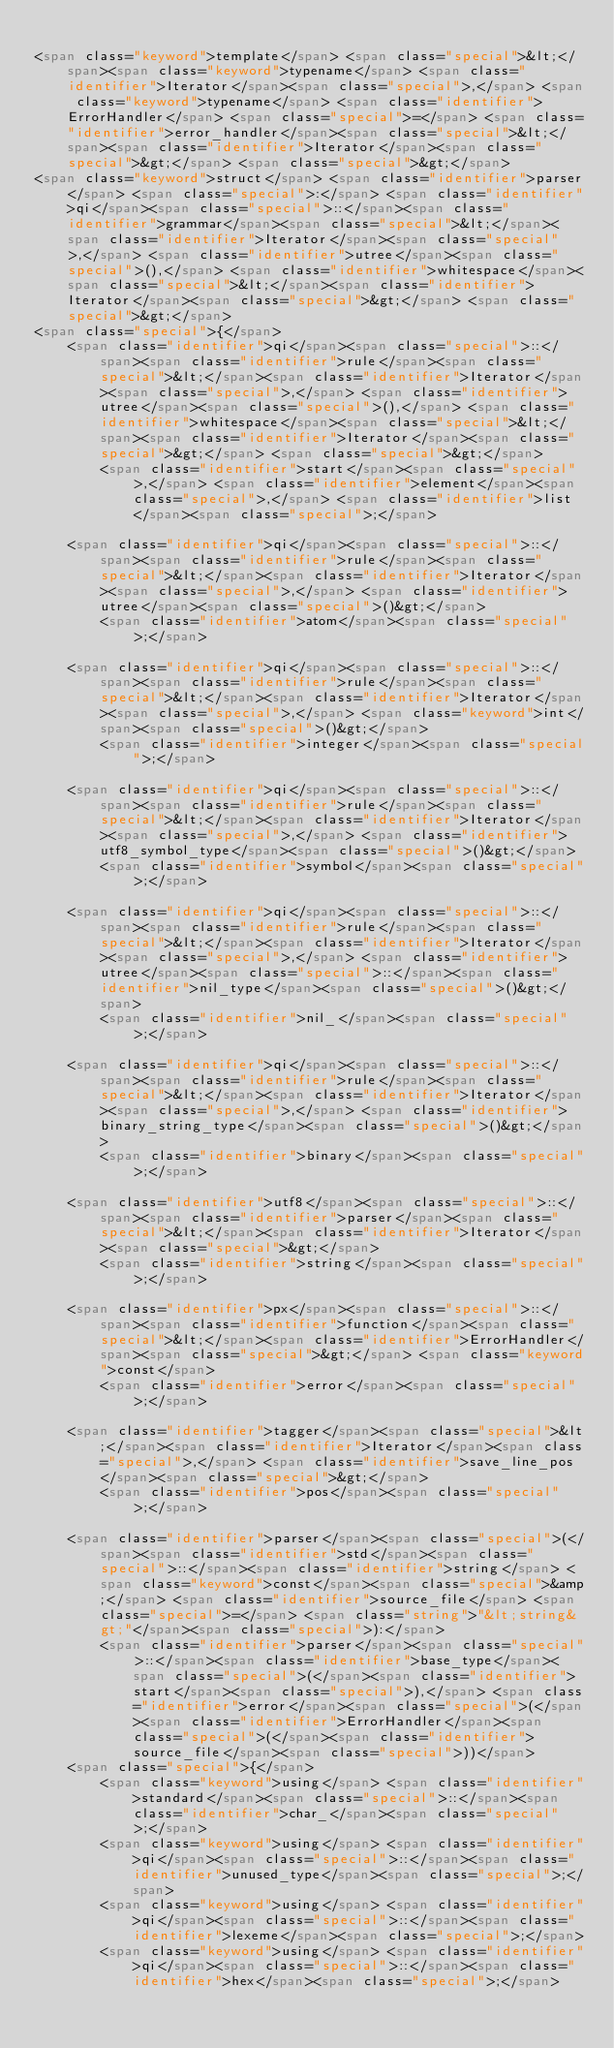<code> <loc_0><loc_0><loc_500><loc_500><_HTML_>
<span class="keyword">template</span> <span class="special">&lt;</span><span class="keyword">typename</span> <span class="identifier">Iterator</span><span class="special">,</span> <span class="keyword">typename</span> <span class="identifier">ErrorHandler</span> <span class="special">=</span> <span class="identifier">error_handler</span><span class="special">&lt;</span><span class="identifier">Iterator</span><span class="special">&gt;</span> <span class="special">&gt;</span>
<span class="keyword">struct</span> <span class="identifier">parser</span> <span class="special">:</span> <span class="identifier">qi</span><span class="special">::</span><span class="identifier">grammar</span><span class="special">&lt;</span><span class="identifier">Iterator</span><span class="special">,</span> <span class="identifier">utree</span><span class="special">(),</span> <span class="identifier">whitespace</span><span class="special">&lt;</span><span class="identifier">Iterator</span><span class="special">&gt;</span> <span class="special">&gt;</span>
<span class="special">{</span>
    <span class="identifier">qi</span><span class="special">::</span><span class="identifier">rule</span><span class="special">&lt;</span><span class="identifier">Iterator</span><span class="special">,</span> <span class="identifier">utree</span><span class="special">(),</span> <span class="identifier">whitespace</span><span class="special">&lt;</span><span class="identifier">Iterator</span><span class="special">&gt;</span> <span class="special">&gt;</span>
        <span class="identifier">start</span><span class="special">,</span> <span class="identifier">element</span><span class="special">,</span> <span class="identifier">list</span><span class="special">;</span>

    <span class="identifier">qi</span><span class="special">::</span><span class="identifier">rule</span><span class="special">&lt;</span><span class="identifier">Iterator</span><span class="special">,</span> <span class="identifier">utree</span><span class="special">()&gt;</span>
        <span class="identifier">atom</span><span class="special">;</span>

    <span class="identifier">qi</span><span class="special">::</span><span class="identifier">rule</span><span class="special">&lt;</span><span class="identifier">Iterator</span><span class="special">,</span> <span class="keyword">int</span><span class="special">()&gt;</span>
        <span class="identifier">integer</span><span class="special">;</span>

    <span class="identifier">qi</span><span class="special">::</span><span class="identifier">rule</span><span class="special">&lt;</span><span class="identifier">Iterator</span><span class="special">,</span> <span class="identifier">utf8_symbol_type</span><span class="special">()&gt;</span>
        <span class="identifier">symbol</span><span class="special">;</span>

    <span class="identifier">qi</span><span class="special">::</span><span class="identifier">rule</span><span class="special">&lt;</span><span class="identifier">Iterator</span><span class="special">,</span> <span class="identifier">utree</span><span class="special">::</span><span class="identifier">nil_type</span><span class="special">()&gt;</span>
        <span class="identifier">nil_</span><span class="special">;</span>

    <span class="identifier">qi</span><span class="special">::</span><span class="identifier">rule</span><span class="special">&lt;</span><span class="identifier">Iterator</span><span class="special">,</span> <span class="identifier">binary_string_type</span><span class="special">()&gt;</span>
        <span class="identifier">binary</span><span class="special">;</span>

    <span class="identifier">utf8</span><span class="special">::</span><span class="identifier">parser</span><span class="special">&lt;</span><span class="identifier">Iterator</span><span class="special">&gt;</span>
        <span class="identifier">string</span><span class="special">;</span>

    <span class="identifier">px</span><span class="special">::</span><span class="identifier">function</span><span class="special">&lt;</span><span class="identifier">ErrorHandler</span><span class="special">&gt;</span> <span class="keyword">const</span>
        <span class="identifier">error</span><span class="special">;</span>

    <span class="identifier">tagger</span><span class="special">&lt;</span><span class="identifier">Iterator</span><span class="special">,</span> <span class="identifier">save_line_pos</span><span class="special">&gt;</span>
        <span class="identifier">pos</span><span class="special">;</span>

    <span class="identifier">parser</span><span class="special">(</span><span class="identifier">std</span><span class="special">::</span><span class="identifier">string</span> <span class="keyword">const</span><span class="special">&amp;</span> <span class="identifier">source_file</span> <span class="special">=</span> <span class="string">"&lt;string&gt;"</span><span class="special">):</span>
        <span class="identifier">parser</span><span class="special">::</span><span class="identifier">base_type</span><span class="special">(</span><span class="identifier">start</span><span class="special">),</span> <span class="identifier">error</span><span class="special">(</span><span class="identifier">ErrorHandler</span><span class="special">(</span><span class="identifier">source_file</span><span class="special">))</span>
    <span class="special">{</span>
        <span class="keyword">using</span> <span class="identifier">standard</span><span class="special">::</span><span class="identifier">char_</span><span class="special">;</span>
        <span class="keyword">using</span> <span class="identifier">qi</span><span class="special">::</span><span class="identifier">unused_type</span><span class="special">;</span>
        <span class="keyword">using</span> <span class="identifier">qi</span><span class="special">::</span><span class="identifier">lexeme</span><span class="special">;</span>
        <span class="keyword">using</span> <span class="identifier">qi</span><span class="special">::</span><span class="identifier">hex</span><span class="special">;</span></code> 